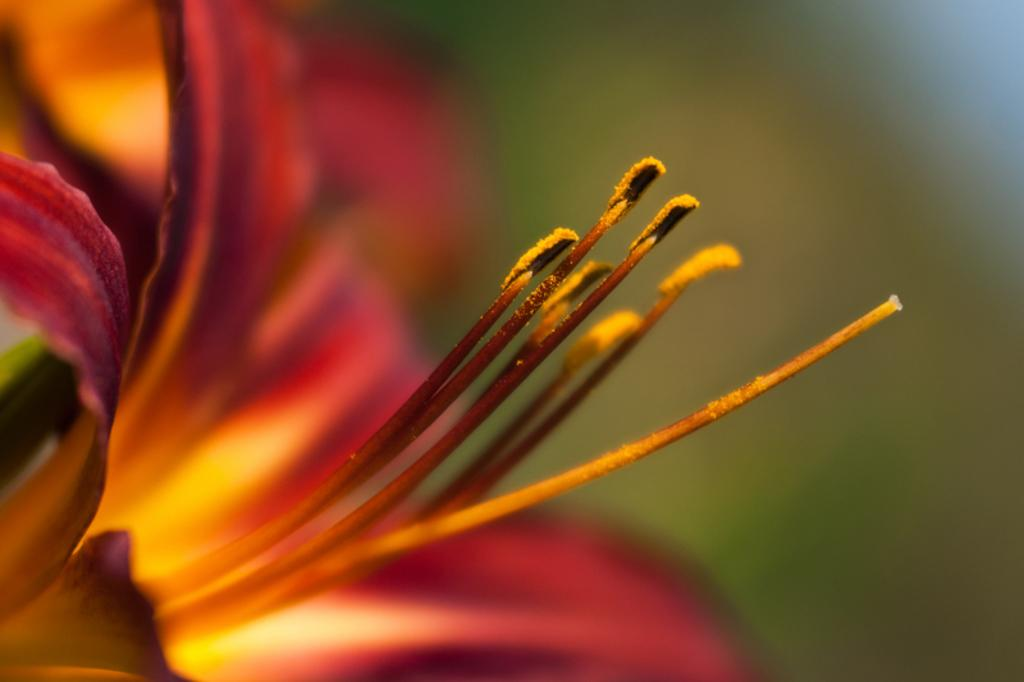What is the main subject of the image? There is a flower in the image. Can you describe the colors of the flower? The flower has red and orange colors. What is the central part of the flower called? The flower has a pistil. What color is the background of the image? The background of the image is green. How is the background of the image depicted? The background is blurred. What emotion does the flower appear to be expressing in the image? The flower is not capable of expressing emotions, as it is an inanimate object. 